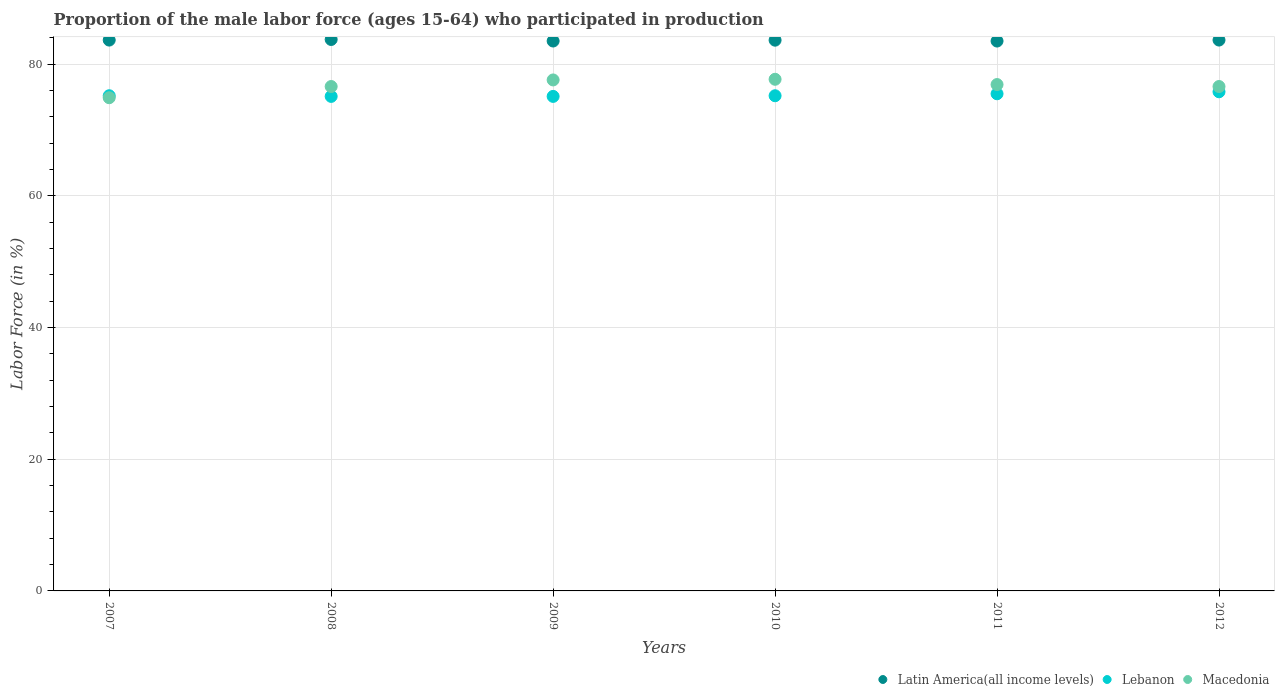How many different coloured dotlines are there?
Give a very brief answer. 3. What is the proportion of the male labor force who participated in production in Macedonia in 2008?
Ensure brevity in your answer.  76.6. Across all years, what is the maximum proportion of the male labor force who participated in production in Macedonia?
Make the answer very short. 77.7. Across all years, what is the minimum proportion of the male labor force who participated in production in Macedonia?
Your answer should be compact. 74.9. In which year was the proportion of the male labor force who participated in production in Latin America(all income levels) maximum?
Provide a succinct answer. 2008. What is the total proportion of the male labor force who participated in production in Lebanon in the graph?
Your answer should be compact. 451.9. What is the difference between the proportion of the male labor force who participated in production in Latin America(all income levels) in 2008 and that in 2012?
Make the answer very short. 0.09. What is the difference between the proportion of the male labor force who participated in production in Lebanon in 2010 and the proportion of the male labor force who participated in production in Latin America(all income levels) in 2008?
Provide a succinct answer. -8.54. What is the average proportion of the male labor force who participated in production in Macedonia per year?
Ensure brevity in your answer.  76.72. In the year 2008, what is the difference between the proportion of the male labor force who participated in production in Macedonia and proportion of the male labor force who participated in production in Latin America(all income levels)?
Your answer should be compact. -7.14. In how many years, is the proportion of the male labor force who participated in production in Latin America(all income levels) greater than 52 %?
Provide a short and direct response. 6. What is the ratio of the proportion of the male labor force who participated in production in Latin America(all income levels) in 2007 to that in 2008?
Provide a succinct answer. 1. What is the difference between the highest and the second highest proportion of the male labor force who participated in production in Latin America(all income levels)?
Your response must be concise. 0.09. What is the difference between the highest and the lowest proportion of the male labor force who participated in production in Latin America(all income levels)?
Provide a succinct answer. 0.24. In how many years, is the proportion of the male labor force who participated in production in Latin America(all income levels) greater than the average proportion of the male labor force who participated in production in Latin America(all income levels) taken over all years?
Provide a short and direct response. 4. Does the proportion of the male labor force who participated in production in Latin America(all income levels) monotonically increase over the years?
Give a very brief answer. No. Is the proportion of the male labor force who participated in production in Macedonia strictly less than the proportion of the male labor force who participated in production in Latin America(all income levels) over the years?
Offer a very short reply. Yes. How many years are there in the graph?
Your response must be concise. 6. What is the difference between two consecutive major ticks on the Y-axis?
Offer a very short reply. 20. Are the values on the major ticks of Y-axis written in scientific E-notation?
Provide a short and direct response. No. Does the graph contain any zero values?
Your response must be concise. No. Does the graph contain grids?
Provide a succinct answer. Yes. How many legend labels are there?
Ensure brevity in your answer.  3. How are the legend labels stacked?
Give a very brief answer. Horizontal. What is the title of the graph?
Offer a terse response. Proportion of the male labor force (ages 15-64) who participated in production. What is the label or title of the Y-axis?
Give a very brief answer. Labor Force (in %). What is the Labor Force (in %) of Latin America(all income levels) in 2007?
Your response must be concise. 83.65. What is the Labor Force (in %) in Lebanon in 2007?
Give a very brief answer. 75.2. What is the Labor Force (in %) in Macedonia in 2007?
Keep it short and to the point. 74.9. What is the Labor Force (in %) of Latin America(all income levels) in 2008?
Make the answer very short. 83.74. What is the Labor Force (in %) in Lebanon in 2008?
Your response must be concise. 75.1. What is the Labor Force (in %) in Macedonia in 2008?
Ensure brevity in your answer.  76.6. What is the Labor Force (in %) in Latin America(all income levels) in 2009?
Make the answer very short. 83.51. What is the Labor Force (in %) of Lebanon in 2009?
Your response must be concise. 75.1. What is the Labor Force (in %) of Macedonia in 2009?
Offer a very short reply. 77.6. What is the Labor Force (in %) of Latin America(all income levels) in 2010?
Provide a short and direct response. 83.64. What is the Labor Force (in %) in Lebanon in 2010?
Give a very brief answer. 75.2. What is the Labor Force (in %) in Macedonia in 2010?
Your response must be concise. 77.7. What is the Labor Force (in %) of Latin America(all income levels) in 2011?
Give a very brief answer. 83.51. What is the Labor Force (in %) in Lebanon in 2011?
Ensure brevity in your answer.  75.5. What is the Labor Force (in %) of Macedonia in 2011?
Offer a very short reply. 76.9. What is the Labor Force (in %) in Latin America(all income levels) in 2012?
Your answer should be very brief. 83.66. What is the Labor Force (in %) of Lebanon in 2012?
Provide a succinct answer. 75.8. What is the Labor Force (in %) in Macedonia in 2012?
Ensure brevity in your answer.  76.6. Across all years, what is the maximum Labor Force (in %) in Latin America(all income levels)?
Offer a very short reply. 83.74. Across all years, what is the maximum Labor Force (in %) of Lebanon?
Keep it short and to the point. 75.8. Across all years, what is the maximum Labor Force (in %) of Macedonia?
Your response must be concise. 77.7. Across all years, what is the minimum Labor Force (in %) of Latin America(all income levels)?
Offer a very short reply. 83.51. Across all years, what is the minimum Labor Force (in %) of Lebanon?
Keep it short and to the point. 75.1. Across all years, what is the minimum Labor Force (in %) in Macedonia?
Your answer should be very brief. 74.9. What is the total Labor Force (in %) of Latin America(all income levels) in the graph?
Keep it short and to the point. 501.7. What is the total Labor Force (in %) of Lebanon in the graph?
Your response must be concise. 451.9. What is the total Labor Force (in %) of Macedonia in the graph?
Provide a short and direct response. 460.3. What is the difference between the Labor Force (in %) of Latin America(all income levels) in 2007 and that in 2008?
Your answer should be very brief. -0.09. What is the difference between the Labor Force (in %) of Latin America(all income levels) in 2007 and that in 2009?
Provide a succinct answer. 0.14. What is the difference between the Labor Force (in %) of Lebanon in 2007 and that in 2009?
Provide a short and direct response. 0.1. What is the difference between the Labor Force (in %) in Latin America(all income levels) in 2007 and that in 2010?
Ensure brevity in your answer.  0.01. What is the difference between the Labor Force (in %) in Macedonia in 2007 and that in 2010?
Give a very brief answer. -2.8. What is the difference between the Labor Force (in %) of Latin America(all income levels) in 2007 and that in 2011?
Give a very brief answer. 0.15. What is the difference between the Labor Force (in %) of Latin America(all income levels) in 2007 and that in 2012?
Provide a succinct answer. -0. What is the difference between the Labor Force (in %) in Lebanon in 2007 and that in 2012?
Ensure brevity in your answer.  -0.6. What is the difference between the Labor Force (in %) of Macedonia in 2007 and that in 2012?
Your answer should be compact. -1.7. What is the difference between the Labor Force (in %) in Latin America(all income levels) in 2008 and that in 2009?
Your answer should be very brief. 0.23. What is the difference between the Labor Force (in %) of Lebanon in 2008 and that in 2009?
Keep it short and to the point. 0. What is the difference between the Labor Force (in %) of Latin America(all income levels) in 2008 and that in 2010?
Your answer should be compact. 0.11. What is the difference between the Labor Force (in %) in Lebanon in 2008 and that in 2010?
Keep it short and to the point. -0.1. What is the difference between the Labor Force (in %) in Macedonia in 2008 and that in 2010?
Your answer should be compact. -1.1. What is the difference between the Labor Force (in %) in Latin America(all income levels) in 2008 and that in 2011?
Provide a succinct answer. 0.24. What is the difference between the Labor Force (in %) of Latin America(all income levels) in 2008 and that in 2012?
Your answer should be compact. 0.09. What is the difference between the Labor Force (in %) of Lebanon in 2008 and that in 2012?
Provide a short and direct response. -0.7. What is the difference between the Labor Force (in %) of Latin America(all income levels) in 2009 and that in 2010?
Give a very brief answer. -0.13. What is the difference between the Labor Force (in %) in Macedonia in 2009 and that in 2010?
Provide a short and direct response. -0.1. What is the difference between the Labor Force (in %) in Latin America(all income levels) in 2009 and that in 2011?
Your response must be concise. 0. What is the difference between the Labor Force (in %) in Macedonia in 2009 and that in 2011?
Keep it short and to the point. 0.7. What is the difference between the Labor Force (in %) in Latin America(all income levels) in 2009 and that in 2012?
Offer a terse response. -0.15. What is the difference between the Labor Force (in %) in Lebanon in 2009 and that in 2012?
Make the answer very short. -0.7. What is the difference between the Labor Force (in %) of Latin America(all income levels) in 2010 and that in 2011?
Provide a succinct answer. 0.13. What is the difference between the Labor Force (in %) in Lebanon in 2010 and that in 2011?
Make the answer very short. -0.3. What is the difference between the Labor Force (in %) in Macedonia in 2010 and that in 2011?
Your answer should be very brief. 0.8. What is the difference between the Labor Force (in %) in Latin America(all income levels) in 2010 and that in 2012?
Keep it short and to the point. -0.02. What is the difference between the Labor Force (in %) in Lebanon in 2010 and that in 2012?
Make the answer very short. -0.6. What is the difference between the Labor Force (in %) of Macedonia in 2010 and that in 2012?
Offer a very short reply. 1.1. What is the difference between the Labor Force (in %) in Latin America(all income levels) in 2011 and that in 2012?
Ensure brevity in your answer.  -0.15. What is the difference between the Labor Force (in %) in Lebanon in 2011 and that in 2012?
Provide a short and direct response. -0.3. What is the difference between the Labor Force (in %) of Macedonia in 2011 and that in 2012?
Offer a terse response. 0.3. What is the difference between the Labor Force (in %) in Latin America(all income levels) in 2007 and the Labor Force (in %) in Lebanon in 2008?
Offer a very short reply. 8.55. What is the difference between the Labor Force (in %) in Latin America(all income levels) in 2007 and the Labor Force (in %) in Macedonia in 2008?
Provide a succinct answer. 7.05. What is the difference between the Labor Force (in %) of Lebanon in 2007 and the Labor Force (in %) of Macedonia in 2008?
Provide a succinct answer. -1.4. What is the difference between the Labor Force (in %) in Latin America(all income levels) in 2007 and the Labor Force (in %) in Lebanon in 2009?
Give a very brief answer. 8.55. What is the difference between the Labor Force (in %) in Latin America(all income levels) in 2007 and the Labor Force (in %) in Macedonia in 2009?
Keep it short and to the point. 6.05. What is the difference between the Labor Force (in %) of Lebanon in 2007 and the Labor Force (in %) of Macedonia in 2009?
Keep it short and to the point. -2.4. What is the difference between the Labor Force (in %) of Latin America(all income levels) in 2007 and the Labor Force (in %) of Lebanon in 2010?
Make the answer very short. 8.45. What is the difference between the Labor Force (in %) of Latin America(all income levels) in 2007 and the Labor Force (in %) of Macedonia in 2010?
Give a very brief answer. 5.95. What is the difference between the Labor Force (in %) of Latin America(all income levels) in 2007 and the Labor Force (in %) of Lebanon in 2011?
Make the answer very short. 8.15. What is the difference between the Labor Force (in %) in Latin America(all income levels) in 2007 and the Labor Force (in %) in Macedonia in 2011?
Offer a very short reply. 6.75. What is the difference between the Labor Force (in %) in Latin America(all income levels) in 2007 and the Labor Force (in %) in Lebanon in 2012?
Your response must be concise. 7.85. What is the difference between the Labor Force (in %) of Latin America(all income levels) in 2007 and the Labor Force (in %) of Macedonia in 2012?
Offer a very short reply. 7.05. What is the difference between the Labor Force (in %) of Lebanon in 2007 and the Labor Force (in %) of Macedonia in 2012?
Give a very brief answer. -1.4. What is the difference between the Labor Force (in %) of Latin America(all income levels) in 2008 and the Labor Force (in %) of Lebanon in 2009?
Offer a very short reply. 8.64. What is the difference between the Labor Force (in %) in Latin America(all income levels) in 2008 and the Labor Force (in %) in Macedonia in 2009?
Offer a very short reply. 6.14. What is the difference between the Labor Force (in %) in Latin America(all income levels) in 2008 and the Labor Force (in %) in Lebanon in 2010?
Your answer should be compact. 8.54. What is the difference between the Labor Force (in %) of Latin America(all income levels) in 2008 and the Labor Force (in %) of Macedonia in 2010?
Your response must be concise. 6.04. What is the difference between the Labor Force (in %) of Latin America(all income levels) in 2008 and the Labor Force (in %) of Lebanon in 2011?
Your response must be concise. 8.24. What is the difference between the Labor Force (in %) in Latin America(all income levels) in 2008 and the Labor Force (in %) in Macedonia in 2011?
Your answer should be very brief. 6.84. What is the difference between the Labor Force (in %) of Lebanon in 2008 and the Labor Force (in %) of Macedonia in 2011?
Give a very brief answer. -1.8. What is the difference between the Labor Force (in %) of Latin America(all income levels) in 2008 and the Labor Force (in %) of Lebanon in 2012?
Your answer should be very brief. 7.94. What is the difference between the Labor Force (in %) in Latin America(all income levels) in 2008 and the Labor Force (in %) in Macedonia in 2012?
Offer a very short reply. 7.14. What is the difference between the Labor Force (in %) of Lebanon in 2008 and the Labor Force (in %) of Macedonia in 2012?
Provide a succinct answer. -1.5. What is the difference between the Labor Force (in %) in Latin America(all income levels) in 2009 and the Labor Force (in %) in Lebanon in 2010?
Provide a succinct answer. 8.31. What is the difference between the Labor Force (in %) of Latin America(all income levels) in 2009 and the Labor Force (in %) of Macedonia in 2010?
Make the answer very short. 5.81. What is the difference between the Labor Force (in %) of Lebanon in 2009 and the Labor Force (in %) of Macedonia in 2010?
Your response must be concise. -2.6. What is the difference between the Labor Force (in %) in Latin America(all income levels) in 2009 and the Labor Force (in %) in Lebanon in 2011?
Offer a very short reply. 8.01. What is the difference between the Labor Force (in %) of Latin America(all income levels) in 2009 and the Labor Force (in %) of Macedonia in 2011?
Keep it short and to the point. 6.61. What is the difference between the Labor Force (in %) in Lebanon in 2009 and the Labor Force (in %) in Macedonia in 2011?
Offer a very short reply. -1.8. What is the difference between the Labor Force (in %) in Latin America(all income levels) in 2009 and the Labor Force (in %) in Lebanon in 2012?
Your answer should be very brief. 7.71. What is the difference between the Labor Force (in %) of Latin America(all income levels) in 2009 and the Labor Force (in %) of Macedonia in 2012?
Provide a succinct answer. 6.91. What is the difference between the Labor Force (in %) in Lebanon in 2009 and the Labor Force (in %) in Macedonia in 2012?
Keep it short and to the point. -1.5. What is the difference between the Labor Force (in %) in Latin America(all income levels) in 2010 and the Labor Force (in %) in Lebanon in 2011?
Provide a short and direct response. 8.14. What is the difference between the Labor Force (in %) in Latin America(all income levels) in 2010 and the Labor Force (in %) in Macedonia in 2011?
Provide a short and direct response. 6.74. What is the difference between the Labor Force (in %) of Latin America(all income levels) in 2010 and the Labor Force (in %) of Lebanon in 2012?
Ensure brevity in your answer.  7.84. What is the difference between the Labor Force (in %) in Latin America(all income levels) in 2010 and the Labor Force (in %) in Macedonia in 2012?
Your answer should be very brief. 7.04. What is the difference between the Labor Force (in %) in Latin America(all income levels) in 2011 and the Labor Force (in %) in Lebanon in 2012?
Your answer should be compact. 7.71. What is the difference between the Labor Force (in %) of Latin America(all income levels) in 2011 and the Labor Force (in %) of Macedonia in 2012?
Offer a terse response. 6.91. What is the average Labor Force (in %) in Latin America(all income levels) per year?
Provide a short and direct response. 83.62. What is the average Labor Force (in %) in Lebanon per year?
Provide a short and direct response. 75.32. What is the average Labor Force (in %) of Macedonia per year?
Your answer should be very brief. 76.72. In the year 2007, what is the difference between the Labor Force (in %) of Latin America(all income levels) and Labor Force (in %) of Lebanon?
Make the answer very short. 8.45. In the year 2007, what is the difference between the Labor Force (in %) of Latin America(all income levels) and Labor Force (in %) of Macedonia?
Provide a short and direct response. 8.75. In the year 2007, what is the difference between the Labor Force (in %) in Lebanon and Labor Force (in %) in Macedonia?
Offer a terse response. 0.3. In the year 2008, what is the difference between the Labor Force (in %) of Latin America(all income levels) and Labor Force (in %) of Lebanon?
Provide a short and direct response. 8.64. In the year 2008, what is the difference between the Labor Force (in %) in Latin America(all income levels) and Labor Force (in %) in Macedonia?
Your response must be concise. 7.14. In the year 2009, what is the difference between the Labor Force (in %) of Latin America(all income levels) and Labor Force (in %) of Lebanon?
Your answer should be very brief. 8.41. In the year 2009, what is the difference between the Labor Force (in %) in Latin America(all income levels) and Labor Force (in %) in Macedonia?
Keep it short and to the point. 5.91. In the year 2010, what is the difference between the Labor Force (in %) in Latin America(all income levels) and Labor Force (in %) in Lebanon?
Offer a very short reply. 8.44. In the year 2010, what is the difference between the Labor Force (in %) of Latin America(all income levels) and Labor Force (in %) of Macedonia?
Provide a succinct answer. 5.94. In the year 2011, what is the difference between the Labor Force (in %) of Latin America(all income levels) and Labor Force (in %) of Lebanon?
Ensure brevity in your answer.  8.01. In the year 2011, what is the difference between the Labor Force (in %) in Latin America(all income levels) and Labor Force (in %) in Macedonia?
Provide a succinct answer. 6.61. In the year 2012, what is the difference between the Labor Force (in %) of Latin America(all income levels) and Labor Force (in %) of Lebanon?
Offer a very short reply. 7.86. In the year 2012, what is the difference between the Labor Force (in %) of Latin America(all income levels) and Labor Force (in %) of Macedonia?
Make the answer very short. 7.06. In the year 2012, what is the difference between the Labor Force (in %) of Lebanon and Labor Force (in %) of Macedonia?
Offer a very short reply. -0.8. What is the ratio of the Labor Force (in %) of Lebanon in 2007 to that in 2008?
Give a very brief answer. 1. What is the ratio of the Labor Force (in %) in Macedonia in 2007 to that in 2008?
Keep it short and to the point. 0.98. What is the ratio of the Labor Force (in %) of Latin America(all income levels) in 2007 to that in 2009?
Your answer should be compact. 1. What is the ratio of the Labor Force (in %) in Macedonia in 2007 to that in 2009?
Keep it short and to the point. 0.97. What is the ratio of the Labor Force (in %) of Latin America(all income levels) in 2007 to that in 2010?
Provide a short and direct response. 1. What is the ratio of the Labor Force (in %) in Macedonia in 2007 to that in 2010?
Your response must be concise. 0.96. What is the ratio of the Labor Force (in %) in Lebanon in 2007 to that in 2011?
Your answer should be very brief. 1. What is the ratio of the Labor Force (in %) in Macedonia in 2007 to that in 2011?
Offer a terse response. 0.97. What is the ratio of the Labor Force (in %) in Latin America(all income levels) in 2007 to that in 2012?
Your answer should be very brief. 1. What is the ratio of the Labor Force (in %) of Macedonia in 2007 to that in 2012?
Give a very brief answer. 0.98. What is the ratio of the Labor Force (in %) in Macedonia in 2008 to that in 2009?
Offer a terse response. 0.99. What is the ratio of the Labor Force (in %) in Latin America(all income levels) in 2008 to that in 2010?
Provide a short and direct response. 1. What is the ratio of the Labor Force (in %) in Lebanon in 2008 to that in 2010?
Provide a short and direct response. 1. What is the ratio of the Labor Force (in %) of Macedonia in 2008 to that in 2010?
Your answer should be very brief. 0.99. What is the ratio of the Labor Force (in %) of Latin America(all income levels) in 2008 to that in 2011?
Ensure brevity in your answer.  1. What is the ratio of the Labor Force (in %) in Macedonia in 2008 to that in 2011?
Make the answer very short. 1. What is the ratio of the Labor Force (in %) of Latin America(all income levels) in 2008 to that in 2012?
Give a very brief answer. 1. What is the ratio of the Labor Force (in %) in Lebanon in 2008 to that in 2012?
Your answer should be compact. 0.99. What is the ratio of the Labor Force (in %) of Lebanon in 2009 to that in 2011?
Offer a very short reply. 0.99. What is the ratio of the Labor Force (in %) of Macedonia in 2009 to that in 2011?
Offer a very short reply. 1.01. What is the ratio of the Labor Force (in %) in Lebanon in 2009 to that in 2012?
Provide a short and direct response. 0.99. What is the ratio of the Labor Force (in %) of Macedonia in 2009 to that in 2012?
Provide a short and direct response. 1.01. What is the ratio of the Labor Force (in %) of Lebanon in 2010 to that in 2011?
Give a very brief answer. 1. What is the ratio of the Labor Force (in %) in Macedonia in 2010 to that in 2011?
Your response must be concise. 1.01. What is the ratio of the Labor Force (in %) in Latin America(all income levels) in 2010 to that in 2012?
Give a very brief answer. 1. What is the ratio of the Labor Force (in %) of Lebanon in 2010 to that in 2012?
Provide a short and direct response. 0.99. What is the ratio of the Labor Force (in %) of Macedonia in 2010 to that in 2012?
Keep it short and to the point. 1.01. What is the ratio of the Labor Force (in %) in Latin America(all income levels) in 2011 to that in 2012?
Ensure brevity in your answer.  1. What is the ratio of the Labor Force (in %) in Lebanon in 2011 to that in 2012?
Offer a very short reply. 1. What is the difference between the highest and the second highest Labor Force (in %) of Latin America(all income levels)?
Your answer should be compact. 0.09. What is the difference between the highest and the second highest Labor Force (in %) in Lebanon?
Ensure brevity in your answer.  0.3. What is the difference between the highest and the second highest Labor Force (in %) in Macedonia?
Keep it short and to the point. 0.1. What is the difference between the highest and the lowest Labor Force (in %) of Latin America(all income levels)?
Provide a short and direct response. 0.24. What is the difference between the highest and the lowest Labor Force (in %) of Lebanon?
Keep it short and to the point. 0.7. What is the difference between the highest and the lowest Labor Force (in %) in Macedonia?
Give a very brief answer. 2.8. 